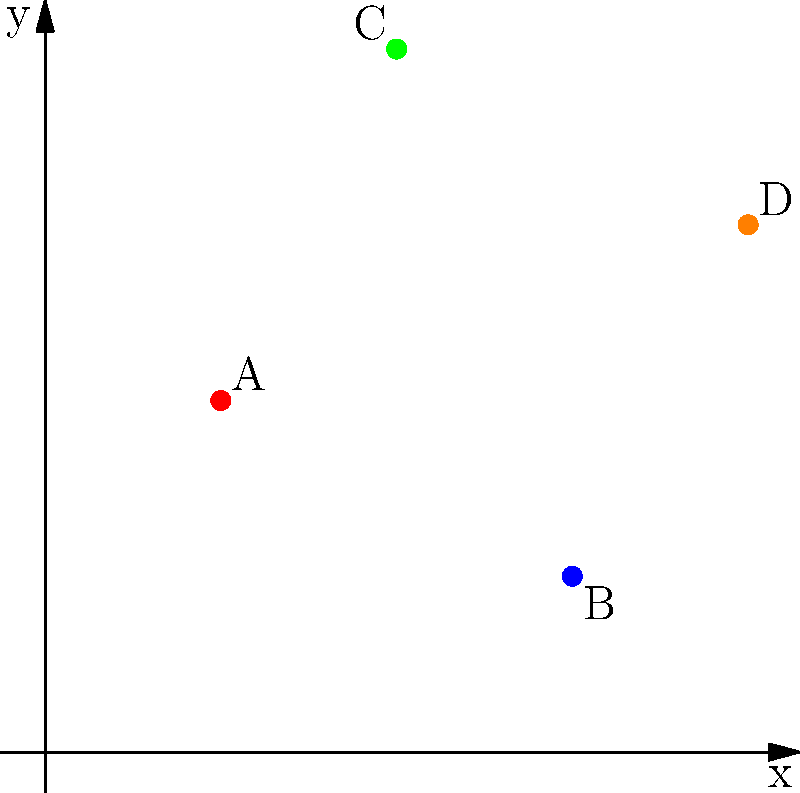In the Cartesian plane above, four hieroglyphic symbols (A, B, C, and D) are plotted. If we consider these symbols as part of a cohesive text, what is the most likely reading order based on their spatial relationships, assuming a left-to-right and top-to-bottom progression typical in Coptic texts? To determine the most likely reading order, we need to analyze the spatial relationships of the hieroglyphic symbols on the Cartesian plane, considering both their x and y coordinates:

1. Symbol A is at (1,2)
2. Symbol B is at (3,1)
3. Symbol C is at (2,4)
4. Symbol D is at (4,3)

Step 1: Identify the leftmost and topmost symbol.
- C has the highest y-coordinate (4), making it the topmost symbol.

Step 2: Determine the next symbol to the right or below.
- A is to the right and below C.

Step 3: Continue the progression.
- D is to the right of A and below the y-coordinate of C.

Step 4: Identify the final symbol.
- B is the rightmost and bottommost symbol.

Therefore, following a left-to-right and top-to-bottom progression typical in Coptic texts, the most likely reading order is C, A, D, B.
Answer: C, A, D, B 